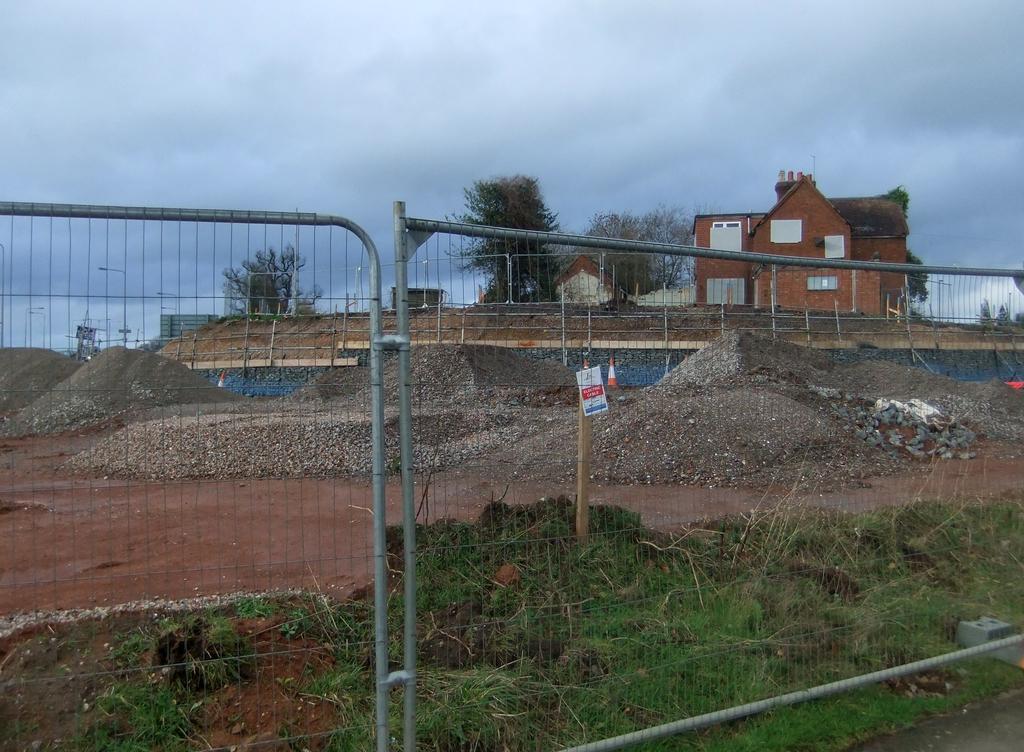How would you summarize this image in a sentence or two? These look like the barricades. I can see the grass. This looks like a wood, which is attached to the pole. I think this is a house. These are the trees. This is the sky. I can see the rocks on the ground. 